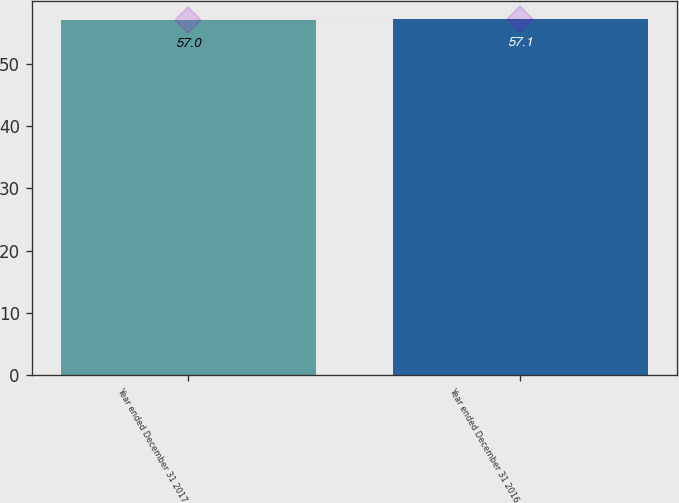Convert chart to OTSL. <chart><loc_0><loc_0><loc_500><loc_500><bar_chart><fcel>Year ended December 31 2017<fcel>Year ended December 31 2016<nl><fcel>57<fcel>57.1<nl></chart> 